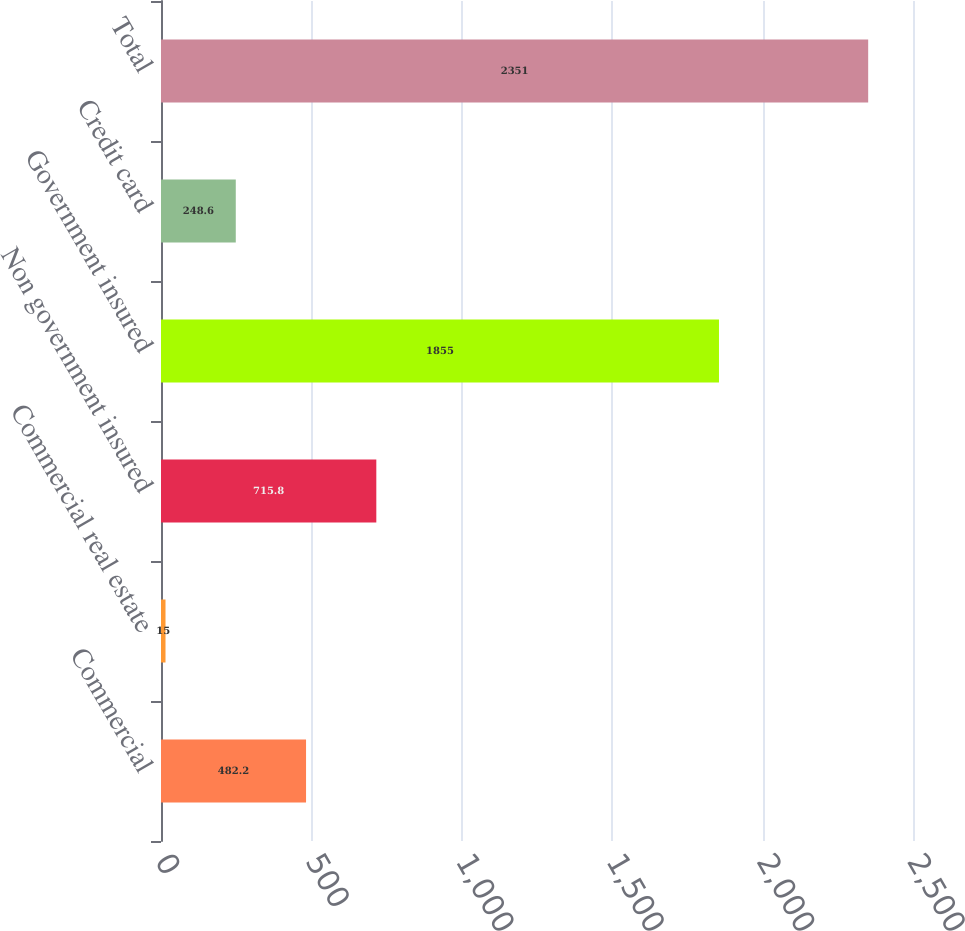<chart> <loc_0><loc_0><loc_500><loc_500><bar_chart><fcel>Commercial<fcel>Commercial real estate<fcel>Non government insured<fcel>Government insured<fcel>Credit card<fcel>Total<nl><fcel>482.2<fcel>15<fcel>715.8<fcel>1855<fcel>248.6<fcel>2351<nl></chart> 